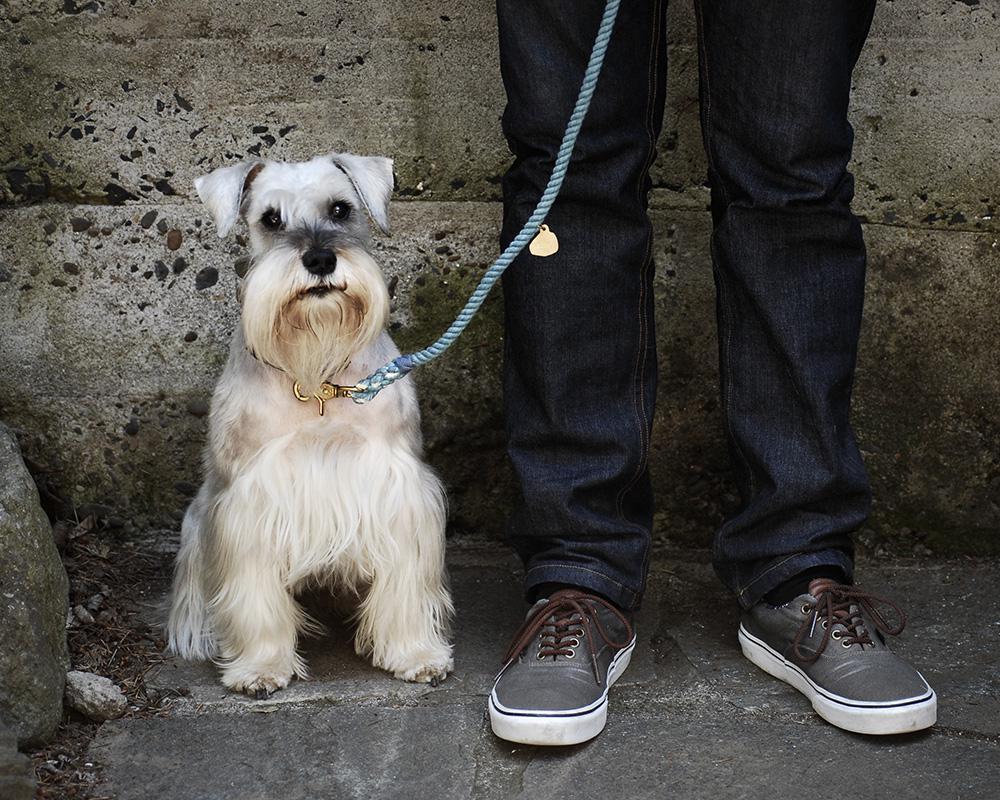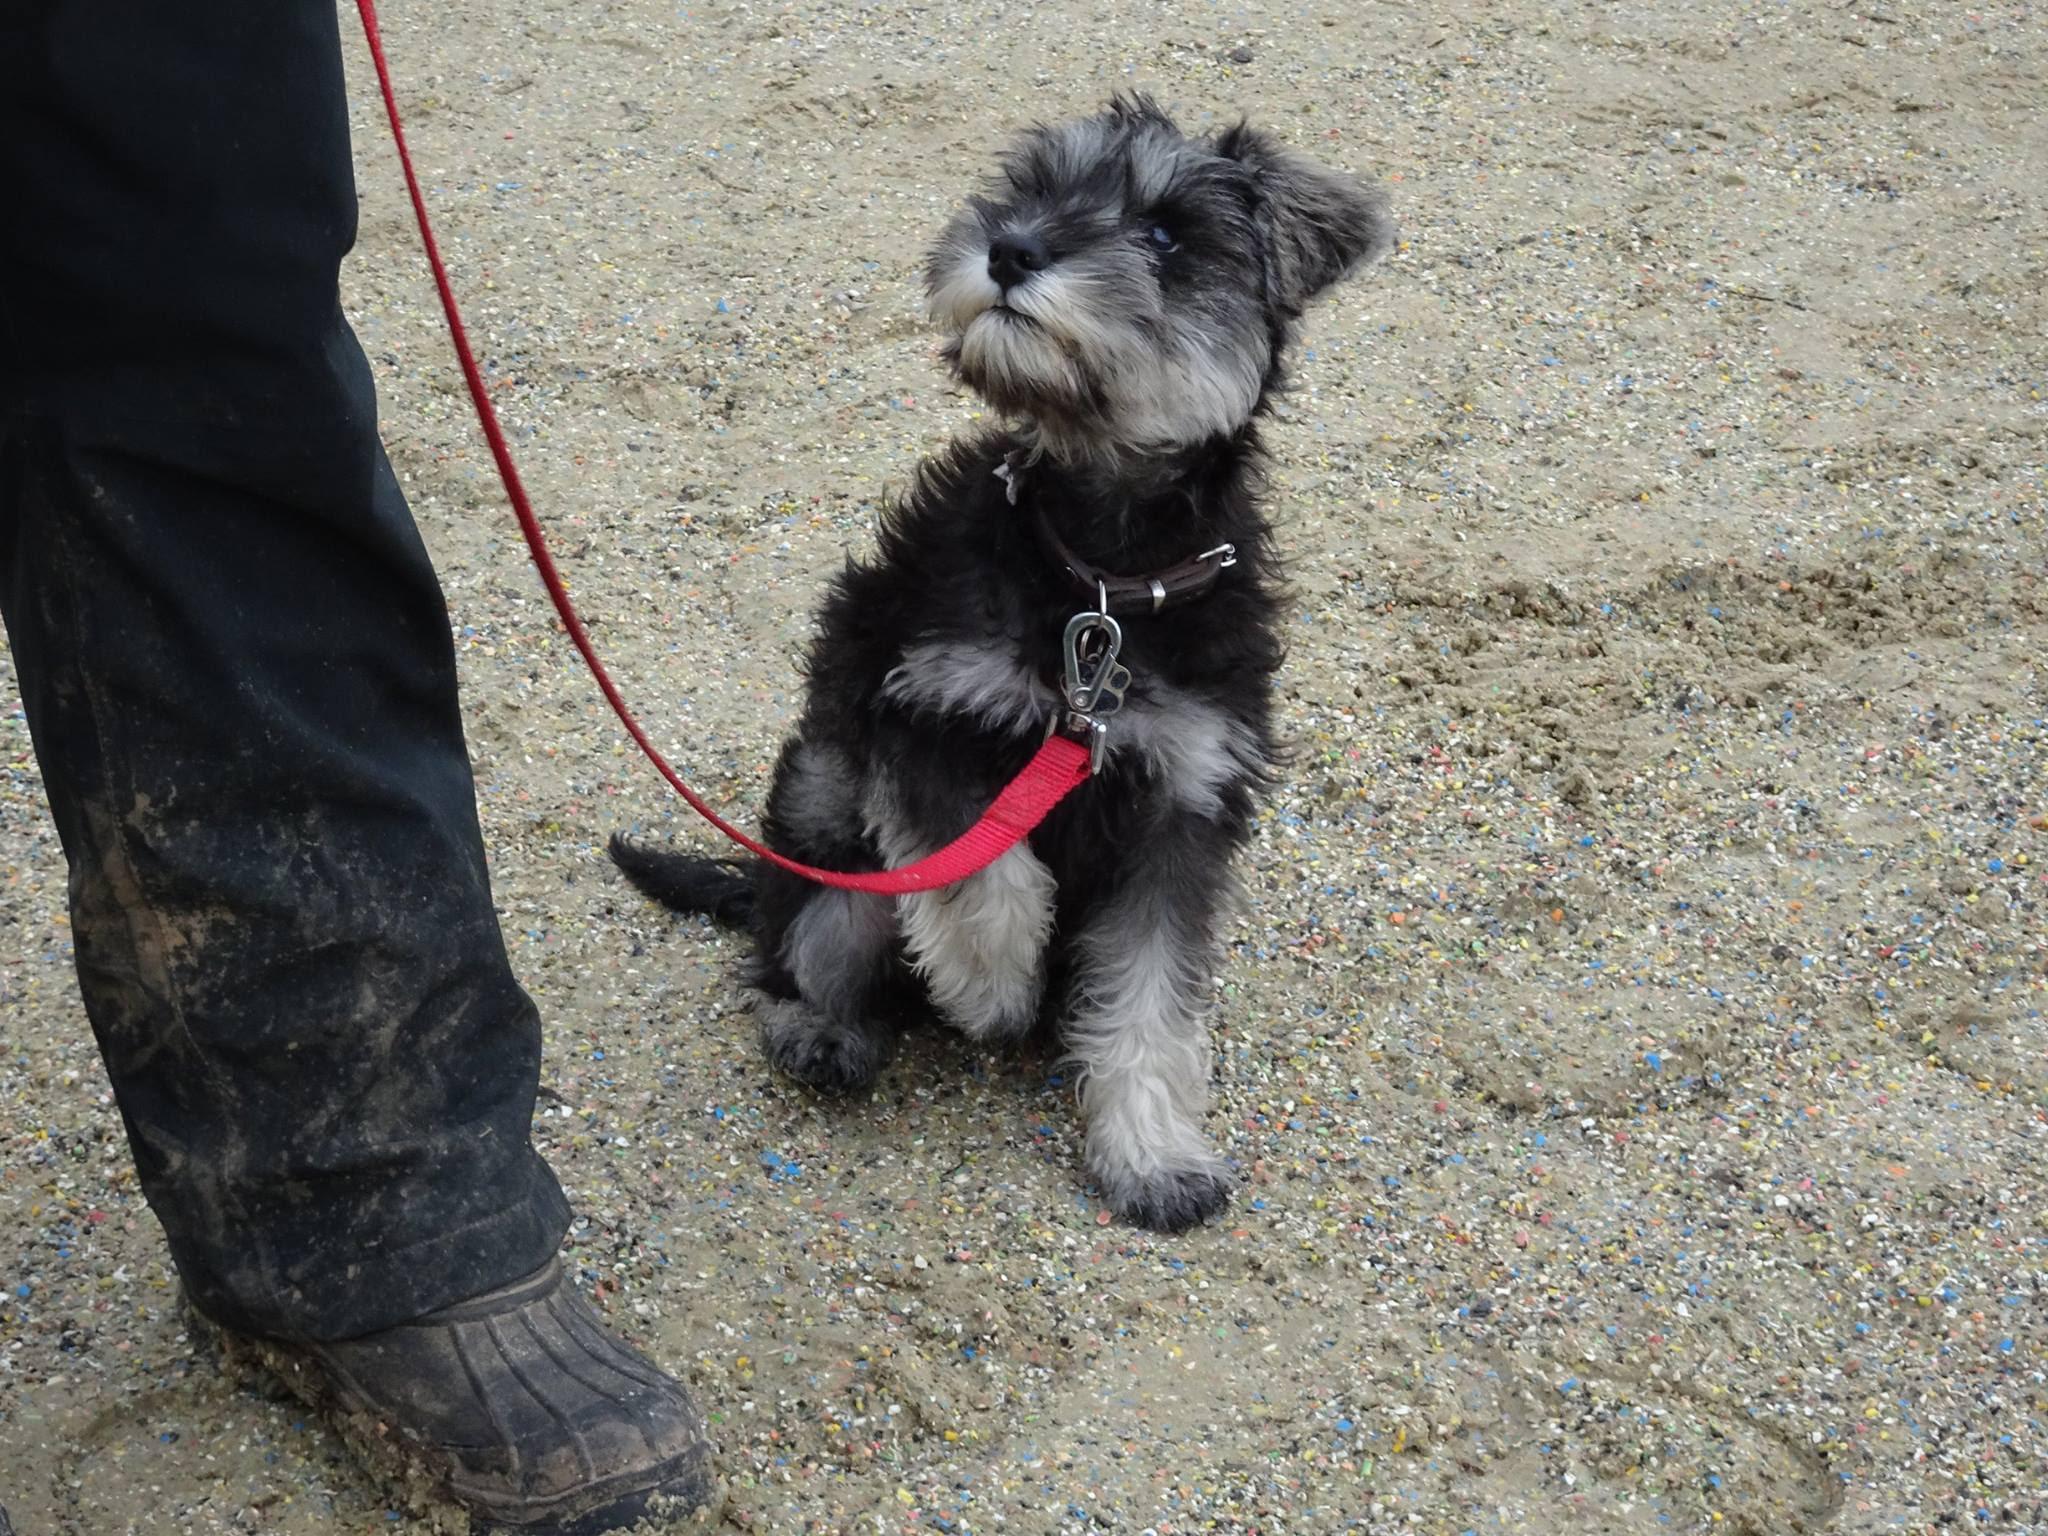The first image is the image on the left, the second image is the image on the right. Assess this claim about the two images: "There are two dogs inside.". Correct or not? Answer yes or no. No. The first image is the image on the left, the second image is the image on the right. Examine the images to the left and right. Is the description "The animal on the right is lying on a green colored surface." accurate? Answer yes or no. No. The first image is the image on the left, the second image is the image on the right. Examine the images to the left and right. Is the description "An image shows a dog with its mouth on some type of chew bone." accurate? Answer yes or no. No. The first image is the image on the left, the second image is the image on the right. For the images displayed, is the sentence "There is a colorful dog toy in the image on the right" factually correct? Answer yes or no. No. 